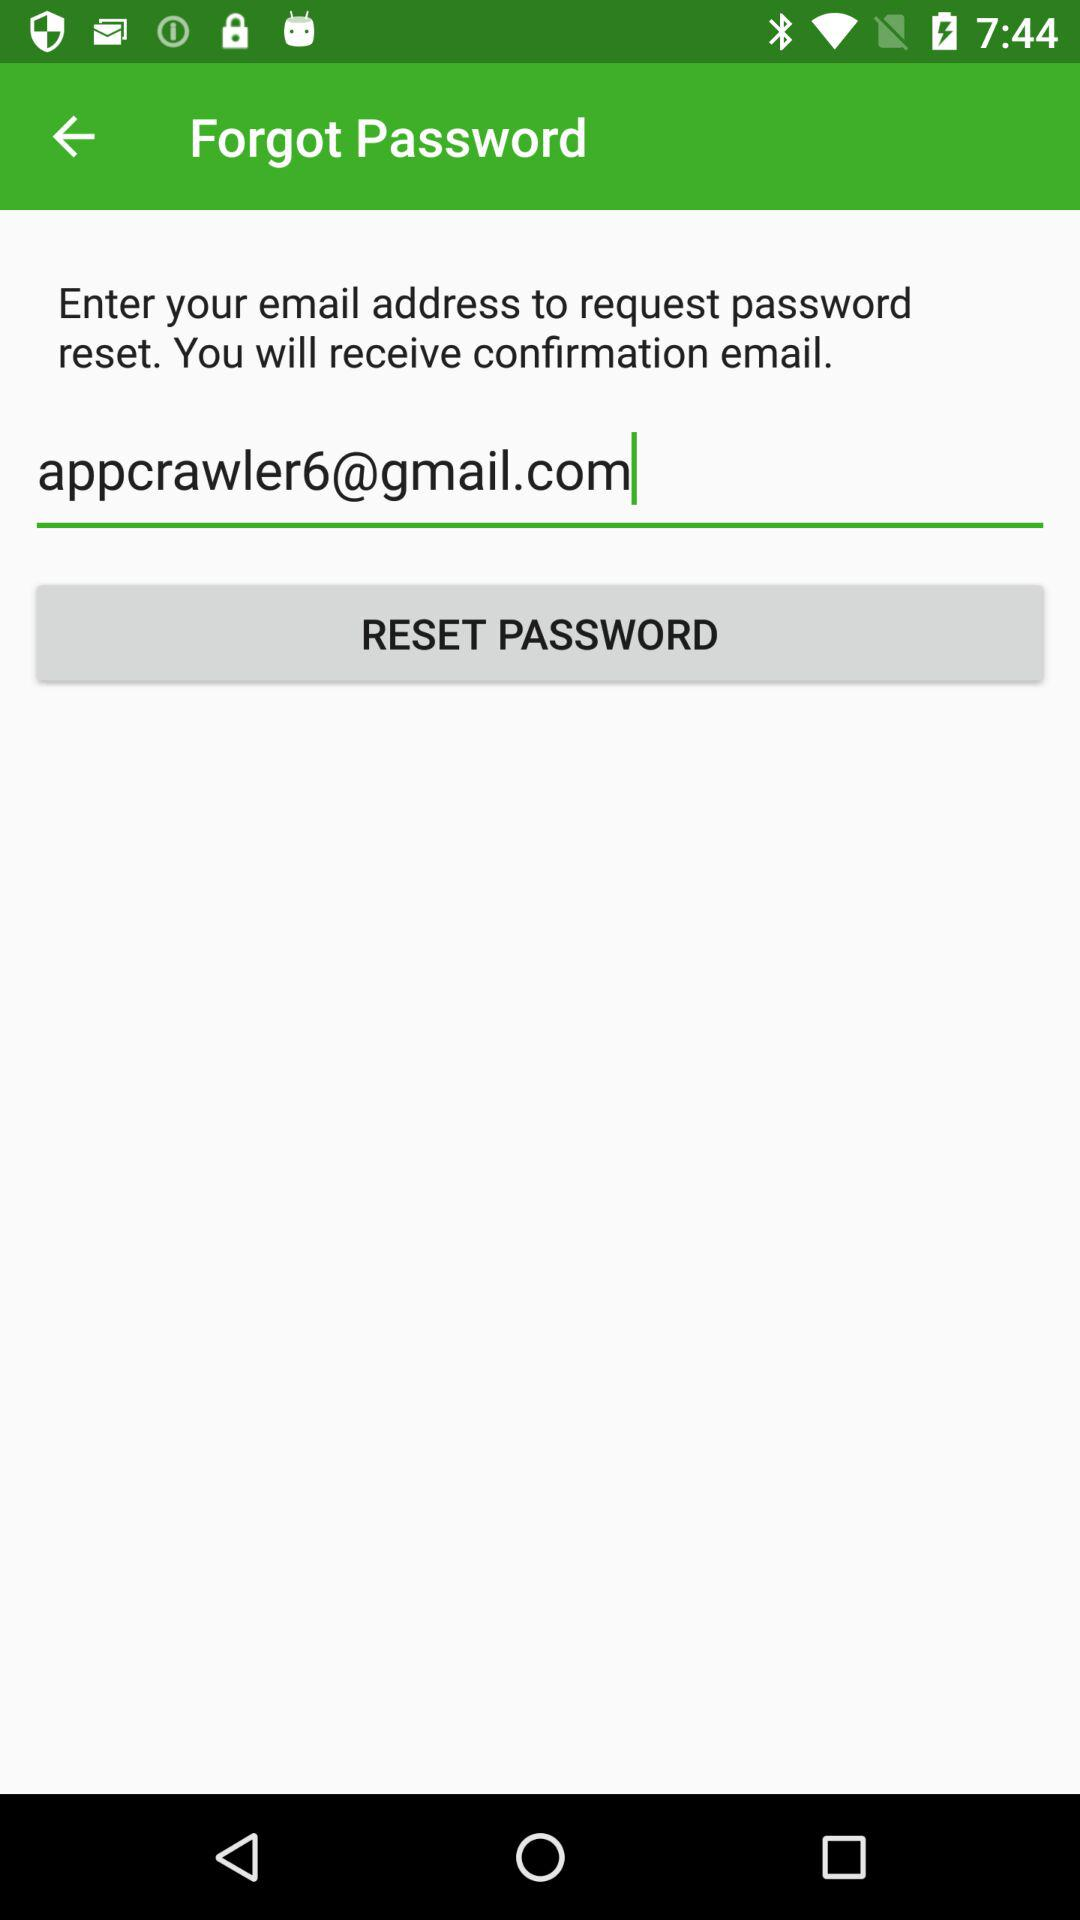What is required to request a password reset? To request a password reset, an email address is required. 